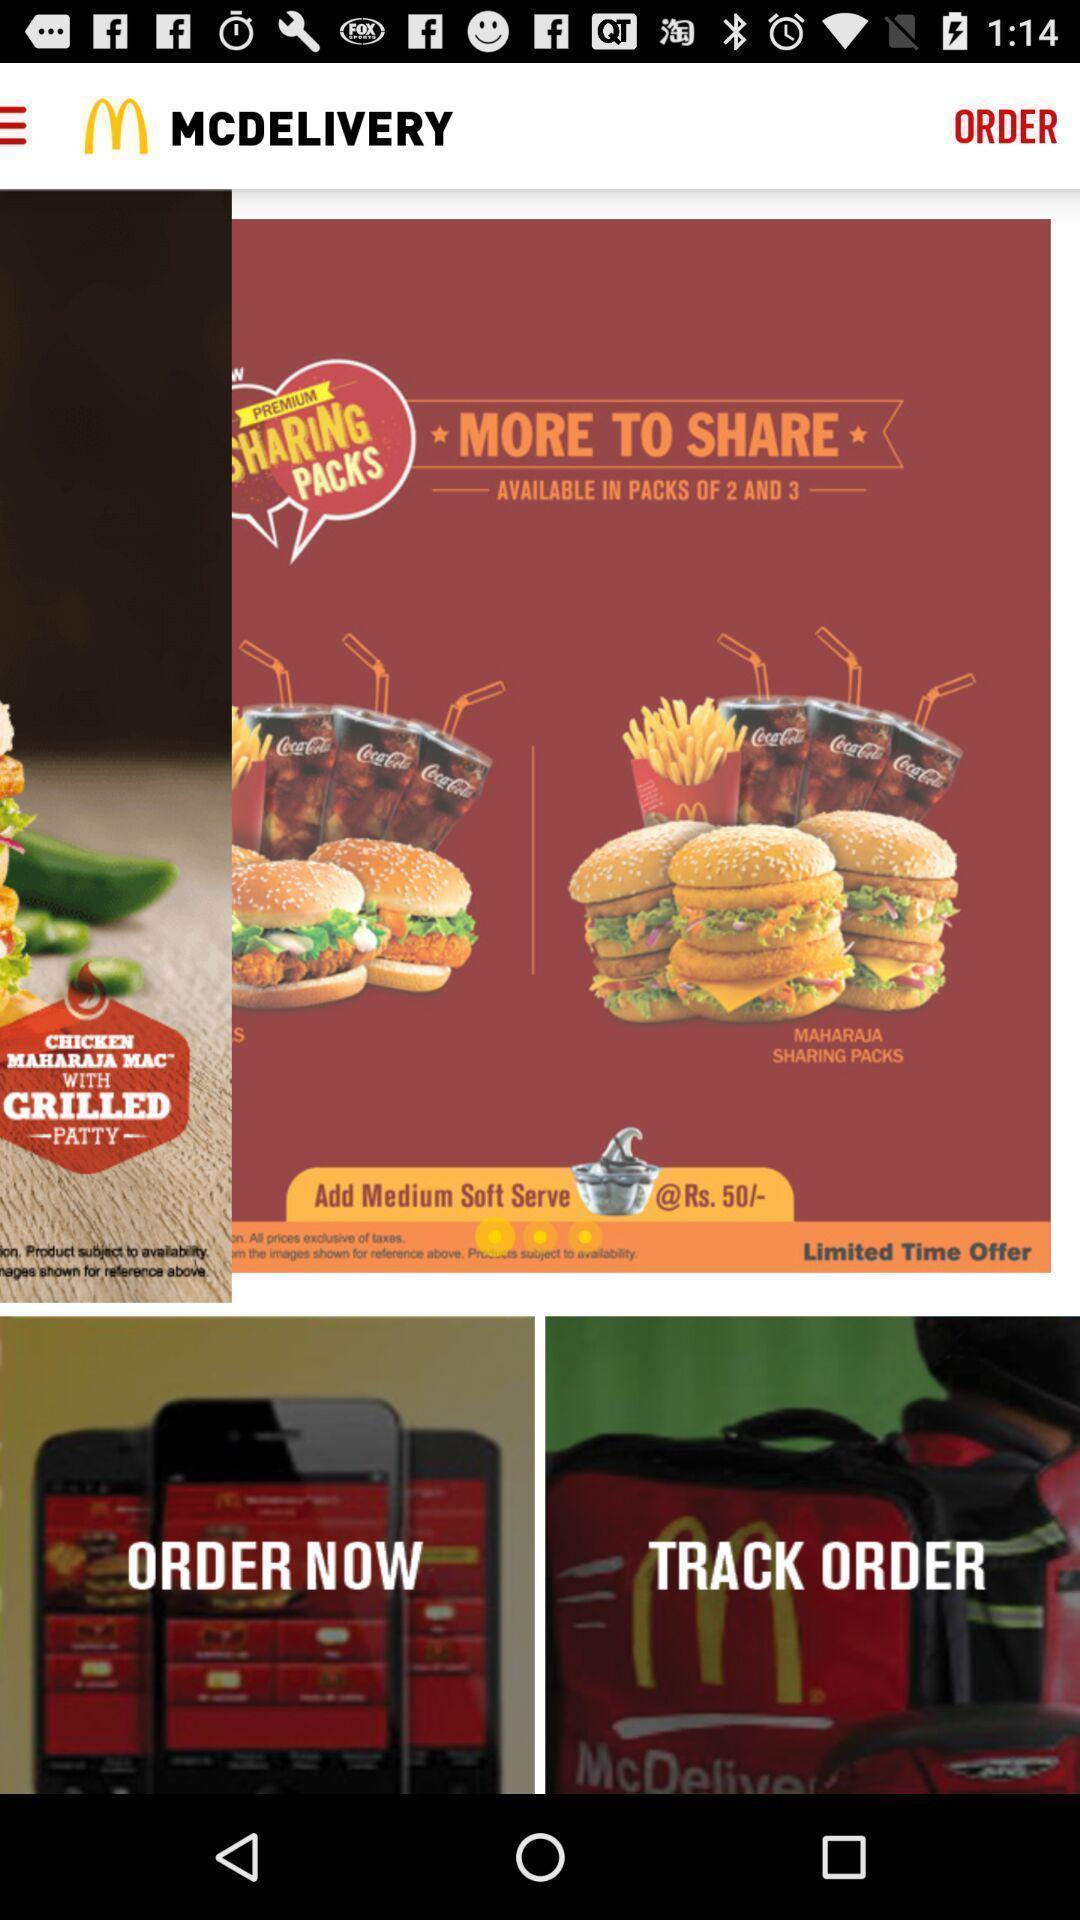Describe this image in words. Welcome page of a food app. 